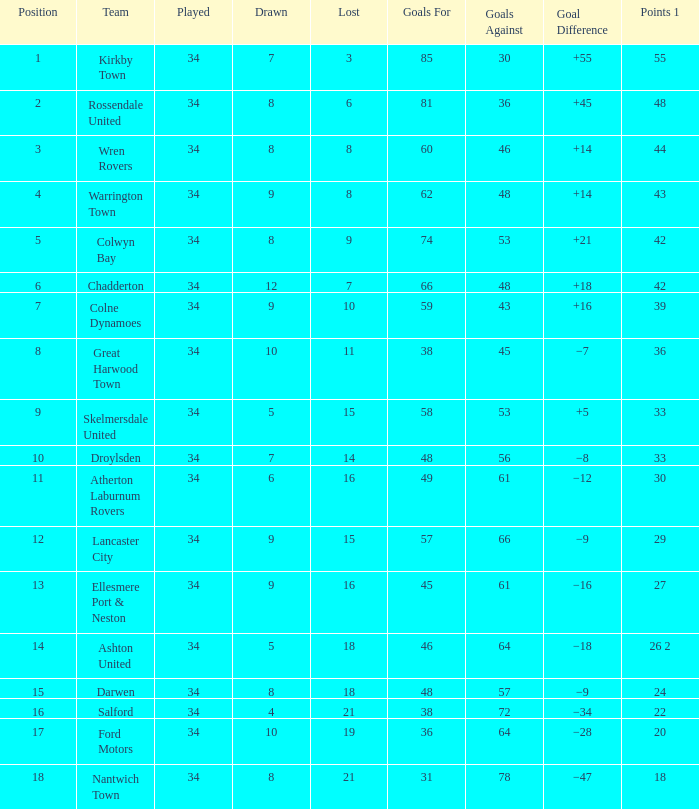What is the cumulative sum of positions when surpassing 48 goals against, 1 among 29 points are played, and less than 34 games have occurred? 0.0. 